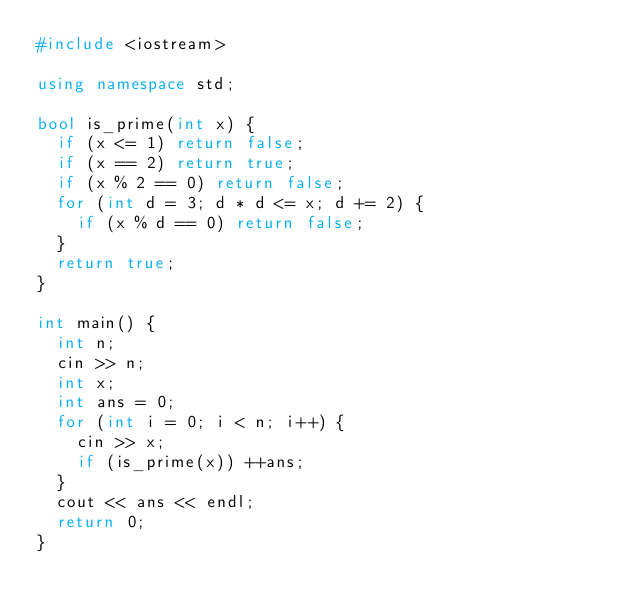Convert code to text. <code><loc_0><loc_0><loc_500><loc_500><_C++_>#include <iostream>

using namespace std;

bool is_prime(int x) {
  if (x <= 1) return false;
  if (x == 2) return true;
  if (x % 2 == 0) return false;
  for (int d = 3; d * d <= x; d += 2) {
    if (x % d == 0) return false;
  }
  return true;
}

int main() {
  int n;
  cin >> n;
  int x;
  int ans = 0;
  for (int i = 0; i < n; i++) {
    cin >> x;
    if (is_prime(x)) ++ans;
  }
  cout << ans << endl;
  return 0;
}

</code> 